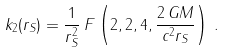Convert formula to latex. <formula><loc_0><loc_0><loc_500><loc_500>k _ { 2 } ( r _ { S } ) = \frac { 1 } { r _ { S } ^ { 2 } } \, F \left ( 2 , 2 , 4 , \frac { 2 \, G M } { c ^ { 2 } r _ { S } } \right ) \, .</formula> 